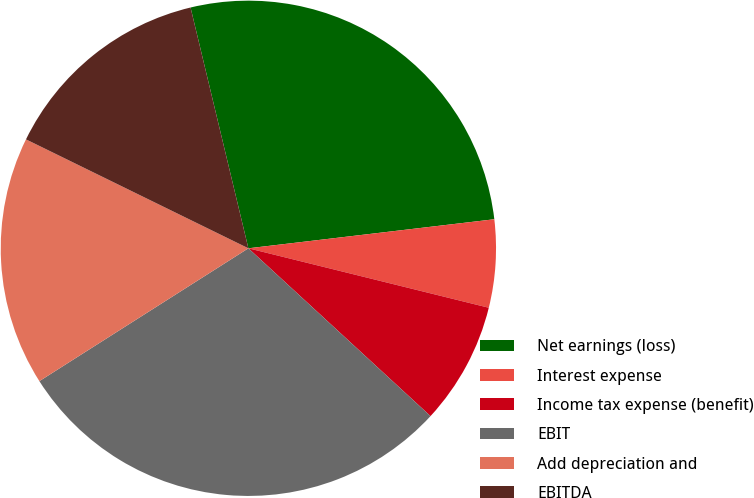<chart> <loc_0><loc_0><loc_500><loc_500><pie_chart><fcel>Net earnings (loss)<fcel>Interest expense<fcel>Income tax expense (benefit)<fcel>EBIT<fcel>Add depreciation and<fcel>EBITDA<nl><fcel>26.88%<fcel>5.73%<fcel>7.99%<fcel>29.14%<fcel>16.26%<fcel>14.0%<nl></chart> 